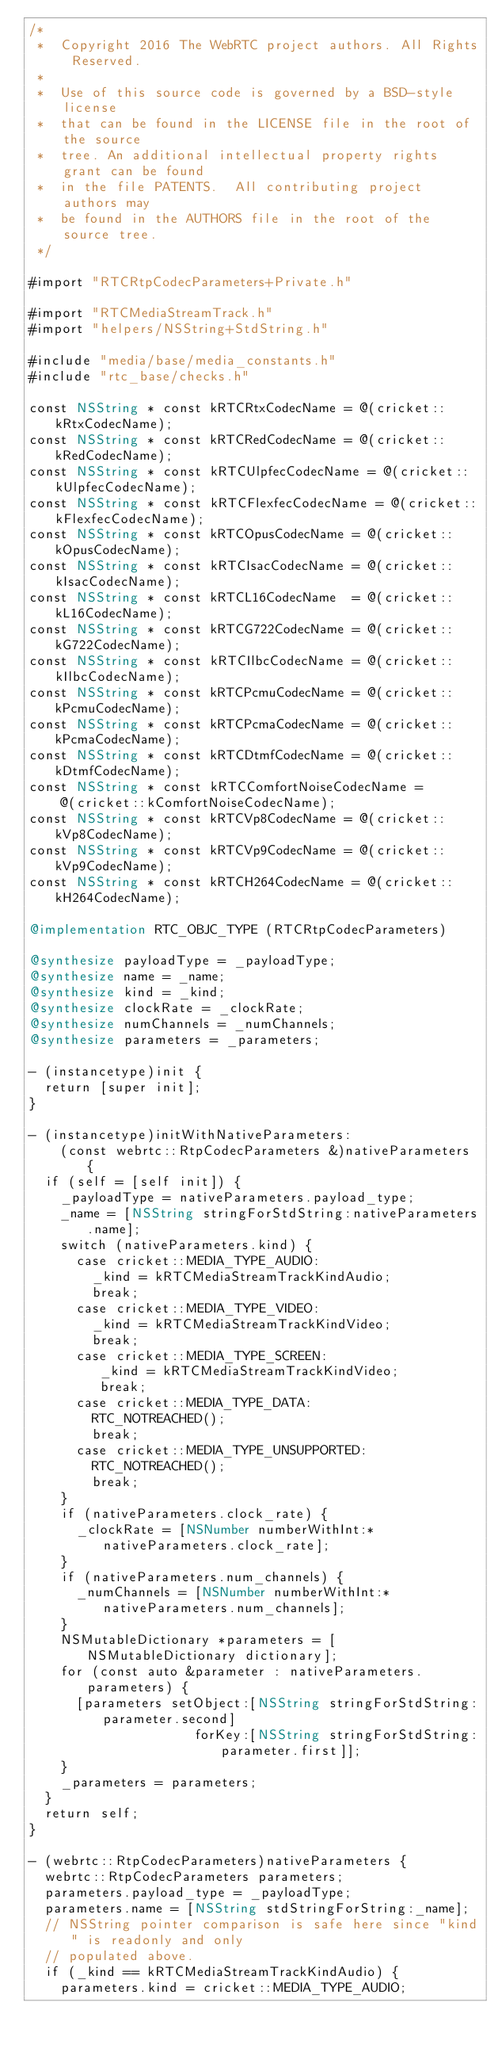Convert code to text. <code><loc_0><loc_0><loc_500><loc_500><_ObjectiveC_>/*
 *  Copyright 2016 The WebRTC project authors. All Rights Reserved.
 *
 *  Use of this source code is governed by a BSD-style license
 *  that can be found in the LICENSE file in the root of the source
 *  tree. An additional intellectual property rights grant can be found
 *  in the file PATENTS.  All contributing project authors may
 *  be found in the AUTHORS file in the root of the source tree.
 */

#import "RTCRtpCodecParameters+Private.h"

#import "RTCMediaStreamTrack.h"
#import "helpers/NSString+StdString.h"

#include "media/base/media_constants.h"
#include "rtc_base/checks.h"

const NSString * const kRTCRtxCodecName = @(cricket::kRtxCodecName);
const NSString * const kRTCRedCodecName = @(cricket::kRedCodecName);
const NSString * const kRTCUlpfecCodecName = @(cricket::kUlpfecCodecName);
const NSString * const kRTCFlexfecCodecName = @(cricket::kFlexfecCodecName);
const NSString * const kRTCOpusCodecName = @(cricket::kOpusCodecName);
const NSString * const kRTCIsacCodecName = @(cricket::kIsacCodecName);
const NSString * const kRTCL16CodecName  = @(cricket::kL16CodecName);
const NSString * const kRTCG722CodecName = @(cricket::kG722CodecName);
const NSString * const kRTCIlbcCodecName = @(cricket::kIlbcCodecName);
const NSString * const kRTCPcmuCodecName = @(cricket::kPcmuCodecName);
const NSString * const kRTCPcmaCodecName = @(cricket::kPcmaCodecName);
const NSString * const kRTCDtmfCodecName = @(cricket::kDtmfCodecName);
const NSString * const kRTCComfortNoiseCodecName =
    @(cricket::kComfortNoiseCodecName);
const NSString * const kRTCVp8CodecName = @(cricket::kVp8CodecName);
const NSString * const kRTCVp9CodecName = @(cricket::kVp9CodecName);
const NSString * const kRTCH264CodecName = @(cricket::kH264CodecName);

@implementation RTC_OBJC_TYPE (RTCRtpCodecParameters)

@synthesize payloadType = _payloadType;
@synthesize name = _name;
@synthesize kind = _kind;
@synthesize clockRate = _clockRate;
@synthesize numChannels = _numChannels;
@synthesize parameters = _parameters;

- (instancetype)init {
  return [super init];
}

- (instancetype)initWithNativeParameters:
    (const webrtc::RtpCodecParameters &)nativeParameters {
  if (self = [self init]) {
    _payloadType = nativeParameters.payload_type;
    _name = [NSString stringForStdString:nativeParameters.name];
    switch (nativeParameters.kind) {
      case cricket::MEDIA_TYPE_AUDIO:
        _kind = kRTCMediaStreamTrackKindAudio;
        break;
      case cricket::MEDIA_TYPE_VIDEO:
        _kind = kRTCMediaStreamTrackKindVideo;
        break;
      case cricket::MEDIA_TYPE_SCREEN:
         _kind = kRTCMediaStreamTrackKindVideo;
         break;
      case cricket::MEDIA_TYPE_DATA:
        RTC_NOTREACHED();
        break;
      case cricket::MEDIA_TYPE_UNSUPPORTED:
        RTC_NOTREACHED();
        break;
    }
    if (nativeParameters.clock_rate) {
      _clockRate = [NSNumber numberWithInt:*nativeParameters.clock_rate];
    }
    if (nativeParameters.num_channels) {
      _numChannels = [NSNumber numberWithInt:*nativeParameters.num_channels];
    }
    NSMutableDictionary *parameters = [NSMutableDictionary dictionary];
    for (const auto &parameter : nativeParameters.parameters) {
      [parameters setObject:[NSString stringForStdString:parameter.second]
                     forKey:[NSString stringForStdString:parameter.first]];
    }
    _parameters = parameters;
  }
  return self;
}

- (webrtc::RtpCodecParameters)nativeParameters {
  webrtc::RtpCodecParameters parameters;
  parameters.payload_type = _payloadType;
  parameters.name = [NSString stdStringForString:_name];
  // NSString pointer comparison is safe here since "kind" is readonly and only
  // populated above.
  if (_kind == kRTCMediaStreamTrackKindAudio) {
    parameters.kind = cricket::MEDIA_TYPE_AUDIO;</code> 